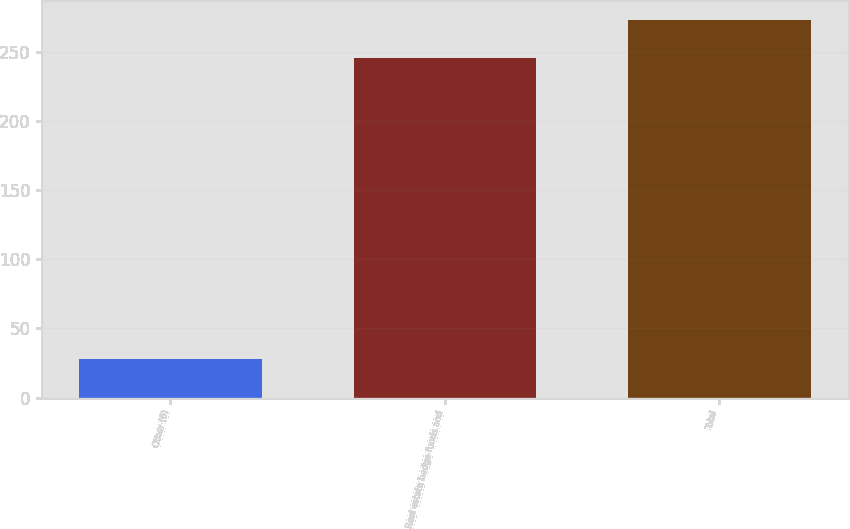Convert chart to OTSL. <chart><loc_0><loc_0><loc_500><loc_500><bar_chart><fcel>Other (6)<fcel>Real estate hedge funds and<fcel>Total<nl><fcel>28<fcel>245<fcel>273<nl></chart> 